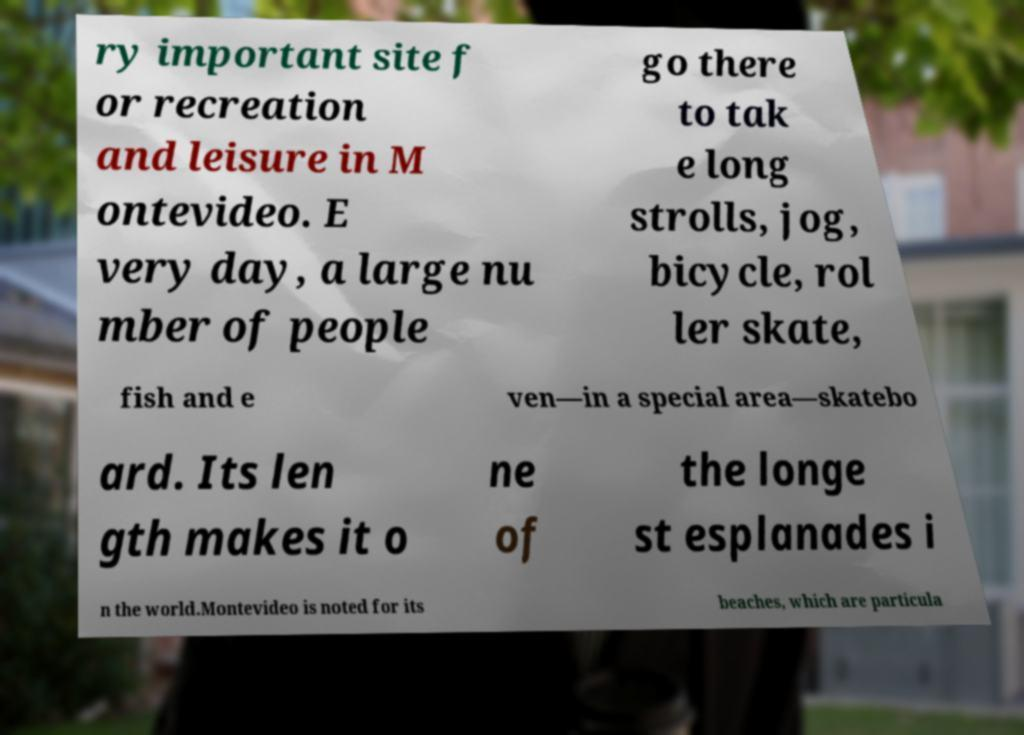Can you read and provide the text displayed in the image?This photo seems to have some interesting text. Can you extract and type it out for me? ry important site f or recreation and leisure in M ontevideo. E very day, a large nu mber of people go there to tak e long strolls, jog, bicycle, rol ler skate, fish and e ven—in a special area—skatebo ard. Its len gth makes it o ne of the longe st esplanades i n the world.Montevideo is noted for its beaches, which are particula 